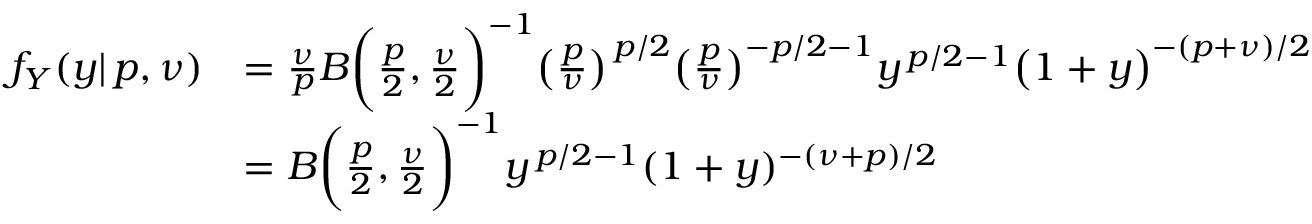<formula> <loc_0><loc_0><loc_500><loc_500>{ \begin{array} { r l } { f _ { Y } ( y | \, p , \nu ) } & { = { \frac { \nu } { p } } B { \left ( } { \frac { p } { 2 } } , { \frac { \nu } { 2 } } { \right ) } ^ { - 1 } { \left ( } { \frac { p } { \nu } } { \right ) } ^ { \, p / 2 } { \left ( } { \frac { p } { \nu } } { \right ) } ^ { - p / 2 - 1 } y ^ { \, p / 2 - 1 } { \left ( } 1 + y { \right ) } ^ { - ( p + \nu ) / 2 } } \\ & { = B { \left ( } { \frac { p } { 2 } } , { \frac { \nu } { 2 } } { \right ) } ^ { - 1 } y ^ { \, p / 2 - 1 } ( 1 + y ) ^ { - ( \nu + p ) / 2 } } \end{array} }</formula> 